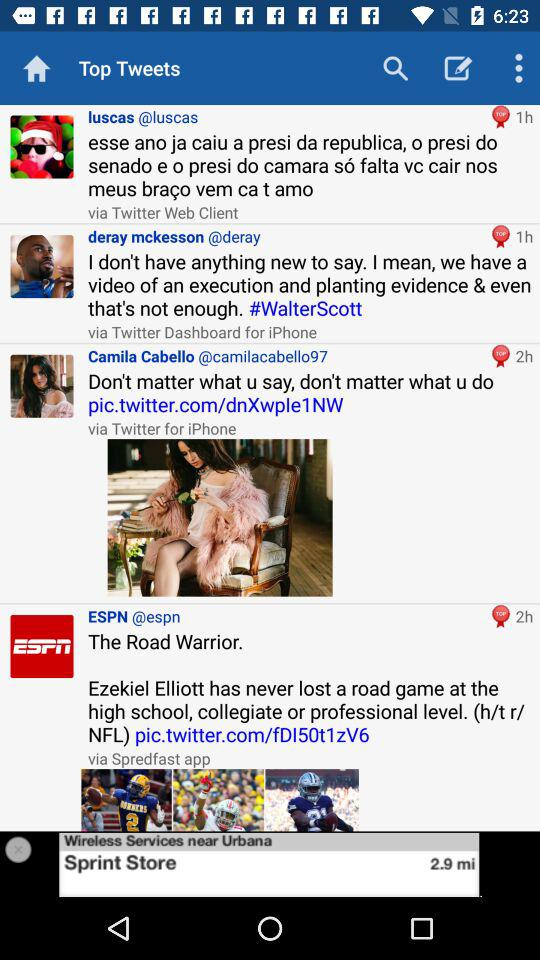How many hours ago did "luscas" update a tweet? Luscas updated a tweet 1 hour ago. 